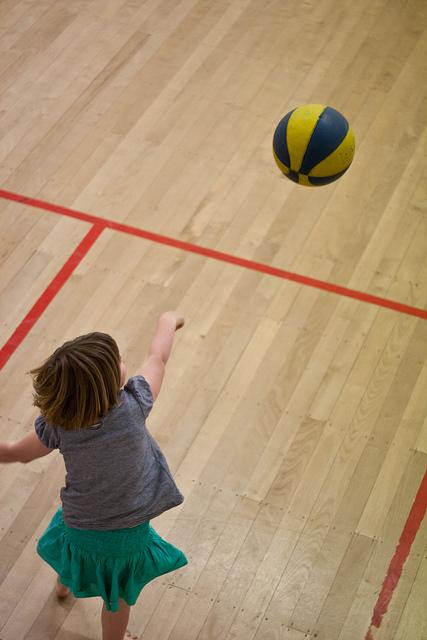Did the girl just throw the ball?
Answer briefly. Yes. What color skirt is the girl wearing?
Keep it brief. Green. How many children in the picture?
Keep it brief. 1. 